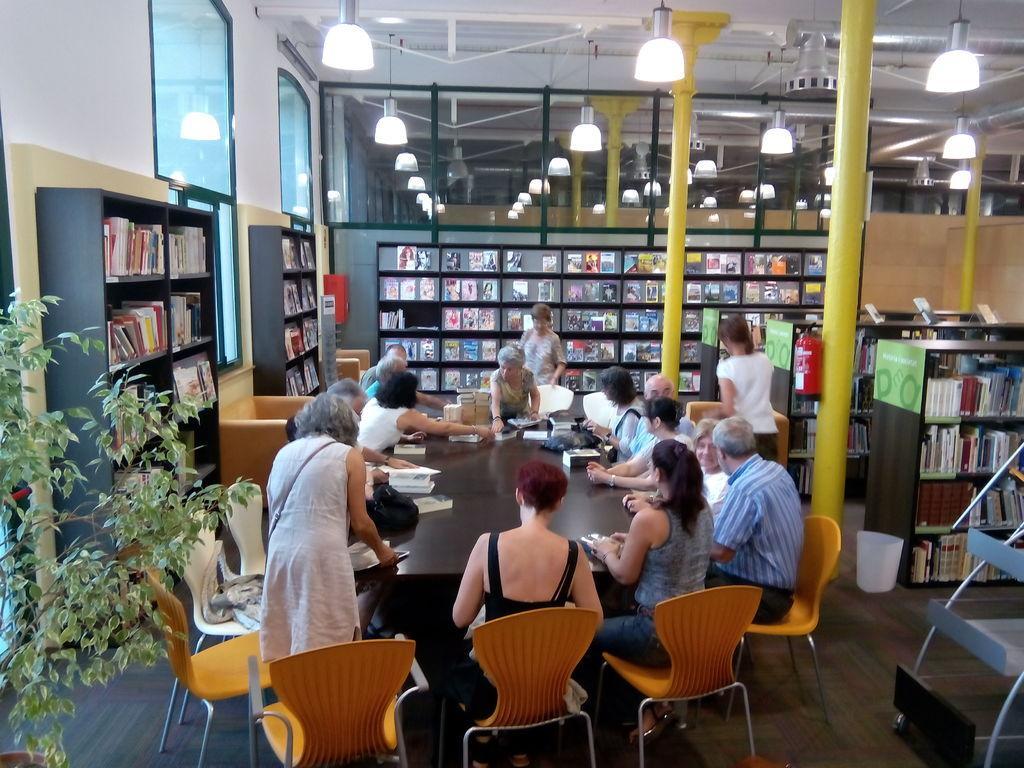Could you give a brief overview of what you see in this image? There are so many people around a table holding a books behind them there is a big bookshelf with books in it. 